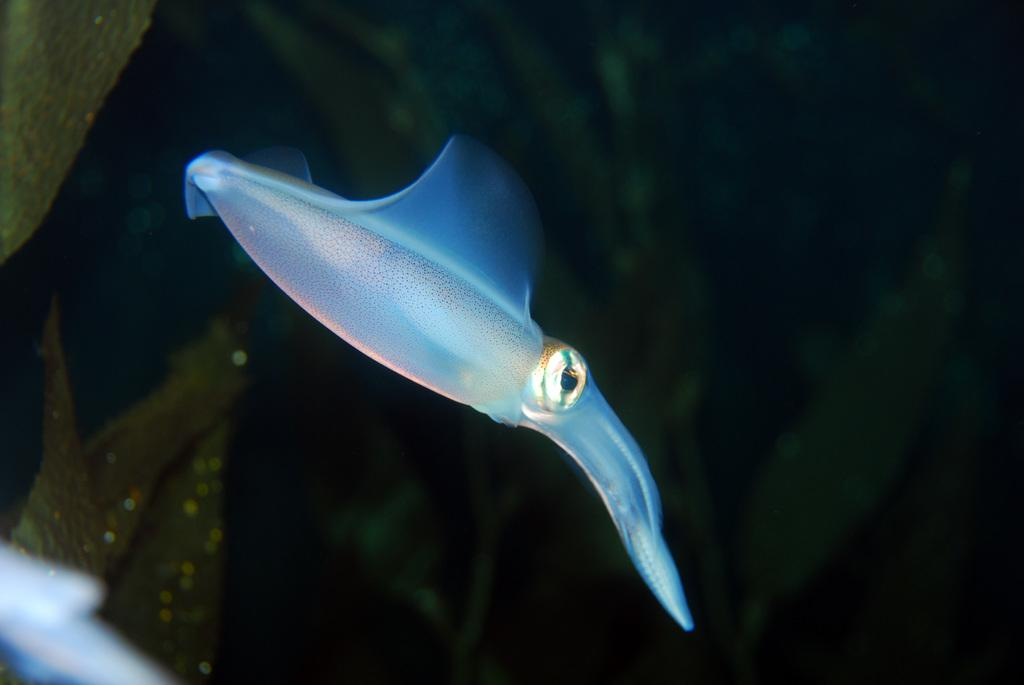What is swimming in the water in the image? There is a squid swimming in the water in the image. What can be seen in the background of the image? There are aqua plants in the background of the image. What type of wood can be seen floating in the water in the image? There is no wood present in the image; it features a squid swimming in the water and aqua plants in the background. 